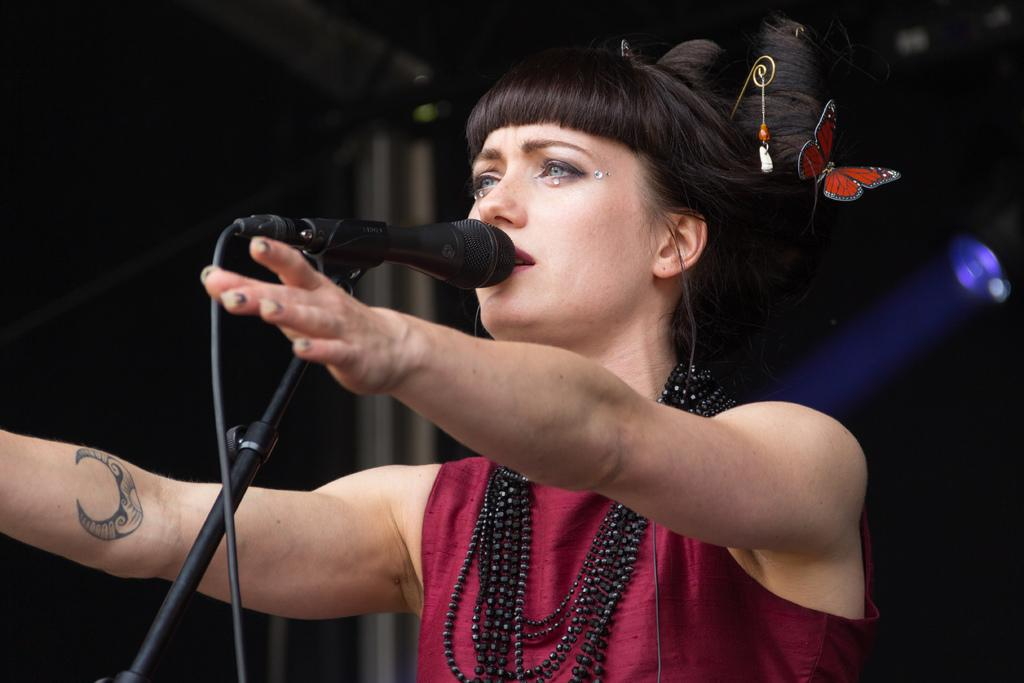Who is the main subject in the image? There is a girl in the middle of the image. What is the girl doing with her hands? The girl has raised her hands. What object is in front of the girl? There is a microphone in front of the girl. What can be seen on the right side of the image? There is a light on the right side of the image. What accessory is the girl wearing in her hair? The girl has hair clips in her hair. What type of plastic material is being used by the girl in the image? There is no plastic material visible in the image. Can you tell me how many quince are on the table in the image? There is no table or quince present in the image. 